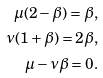<formula> <loc_0><loc_0><loc_500><loc_500>\mu ( 2 - \beta ) = \beta , \\ \nu ( 1 + \beta ) = 2 \beta , \\ \mu - \nu \beta = 0 .</formula> 